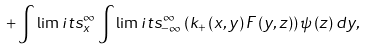<formula> <loc_0><loc_0><loc_500><loc_500>+ \int \lim i t s _ { x } ^ { \infty } \int \lim i t s _ { - \infty } ^ { \infty } \left ( k _ { + } \left ( x , y \right ) F \left ( y , z \right ) \right ) \psi \left ( z \right ) d y ,</formula> 